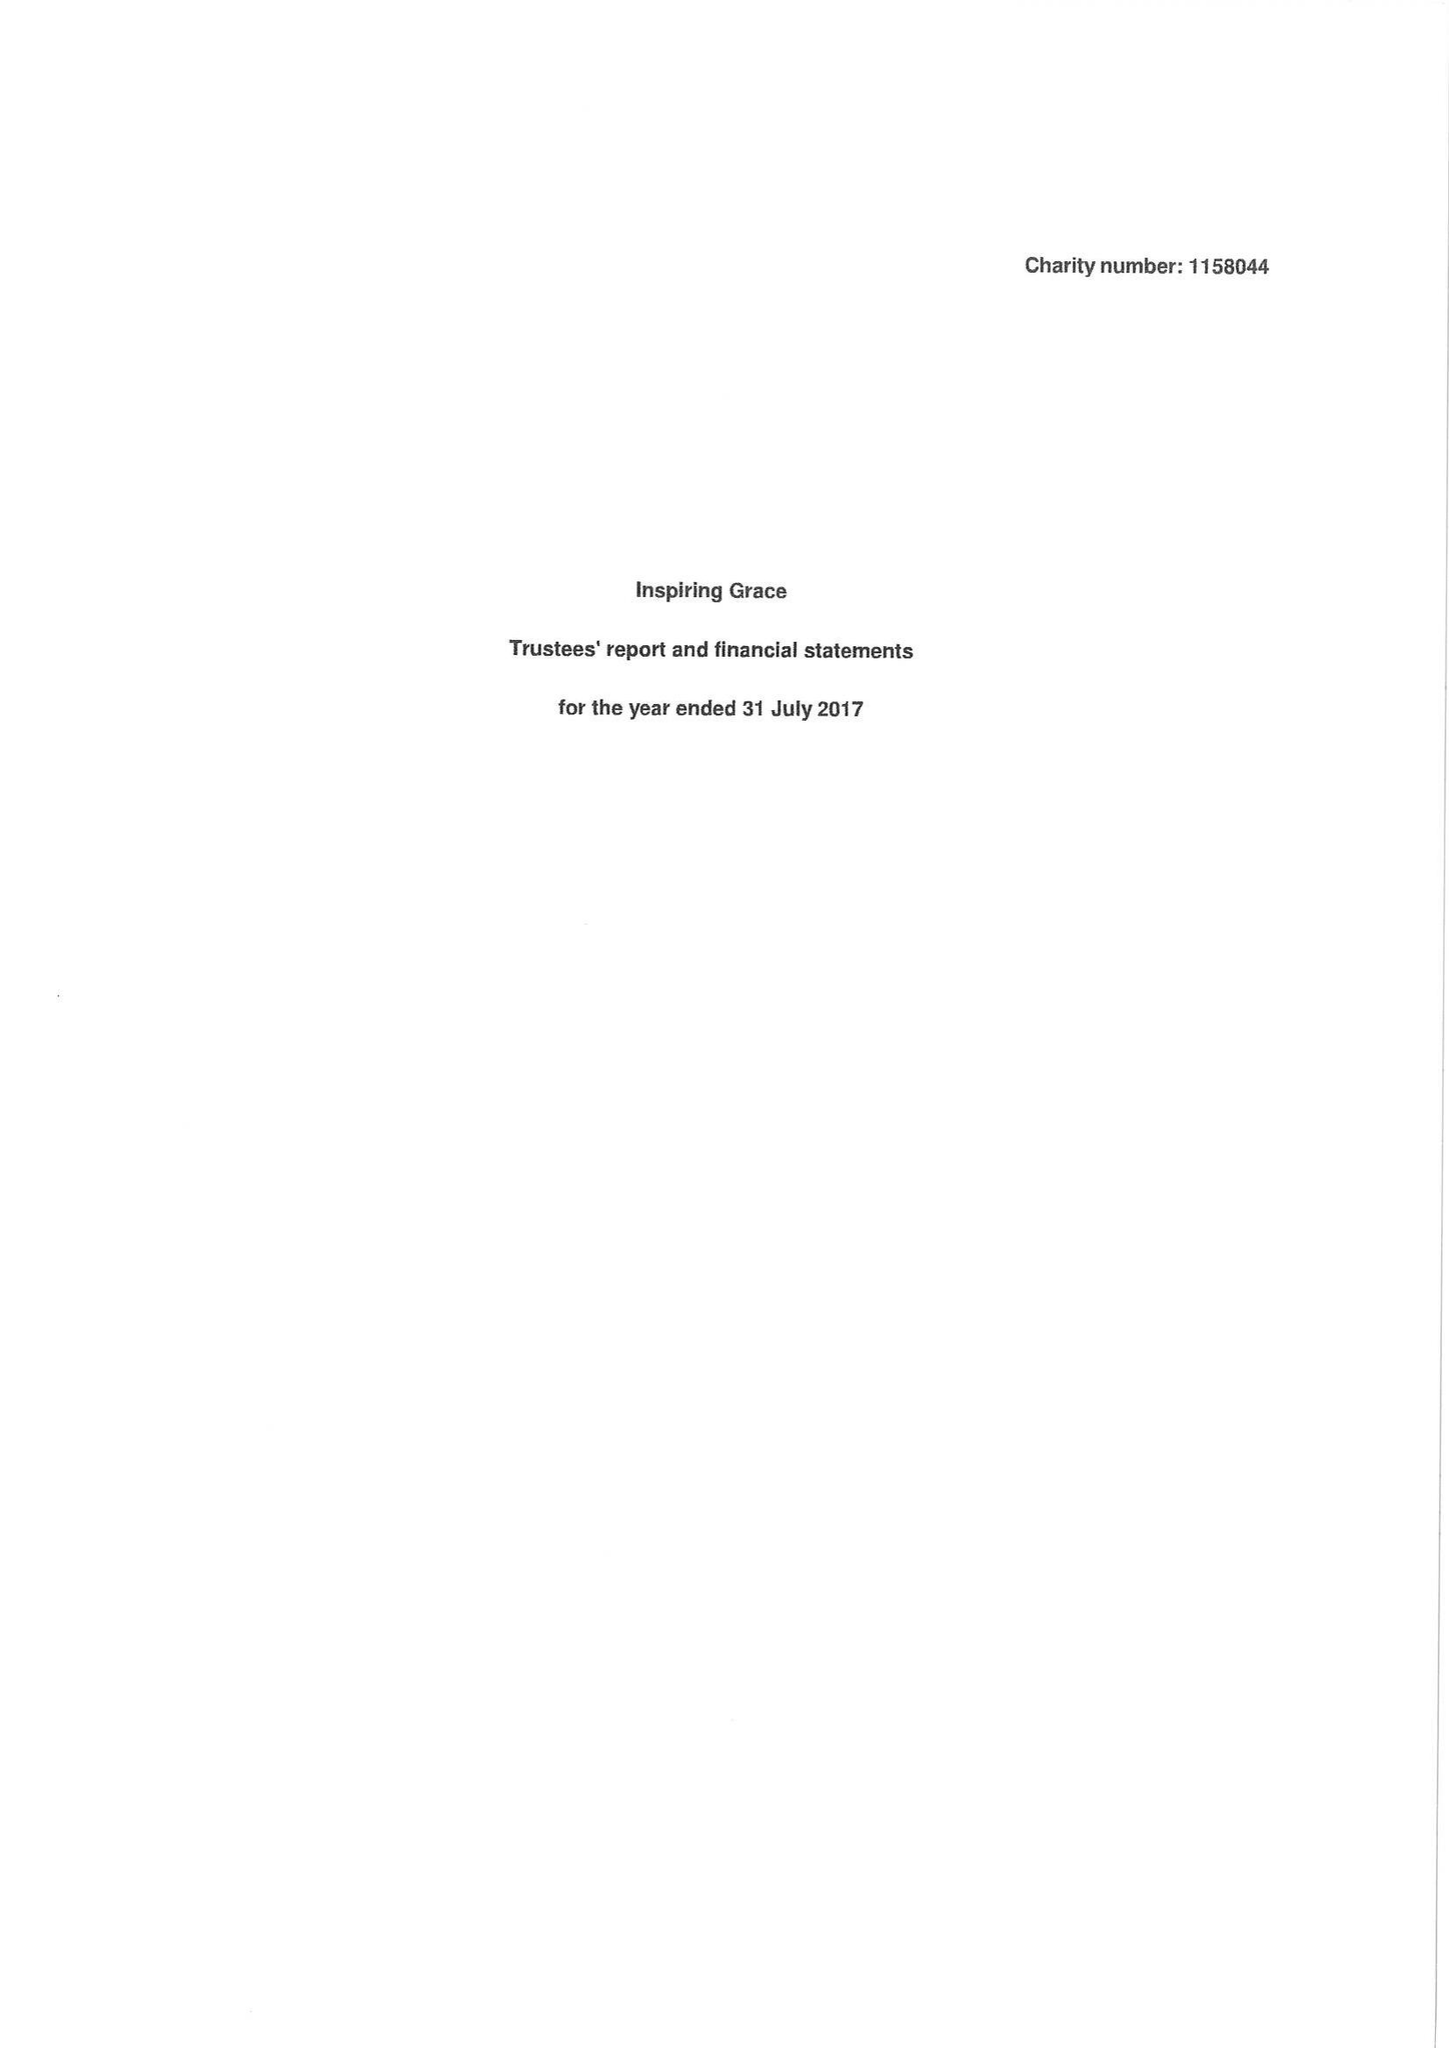What is the value for the report_date?
Answer the question using a single word or phrase. 2017-07-31 